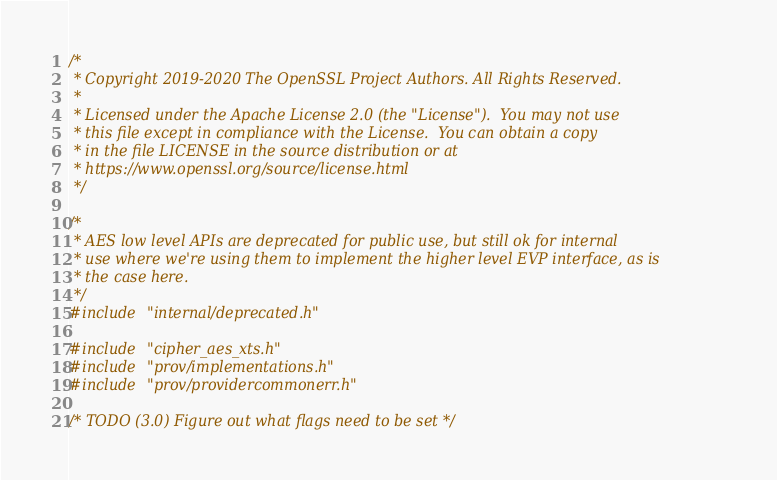<code> <loc_0><loc_0><loc_500><loc_500><_C_>/*
 * Copyright 2019-2020 The OpenSSL Project Authors. All Rights Reserved.
 *
 * Licensed under the Apache License 2.0 (the "License").  You may not use
 * this file except in compliance with the License.  You can obtain a copy
 * in the file LICENSE in the source distribution or at
 * https://www.openssl.org/source/license.html
 */

/*
 * AES low level APIs are deprecated for public use, but still ok for internal
 * use where we're using them to implement the higher level EVP interface, as is
 * the case here.
 */
#include "internal/deprecated.h"

#include "cipher_aes_xts.h"
#include "prov/implementations.h"
#include "prov/providercommonerr.h"

/* TODO (3.0) Figure out what flags need to be set */</code> 